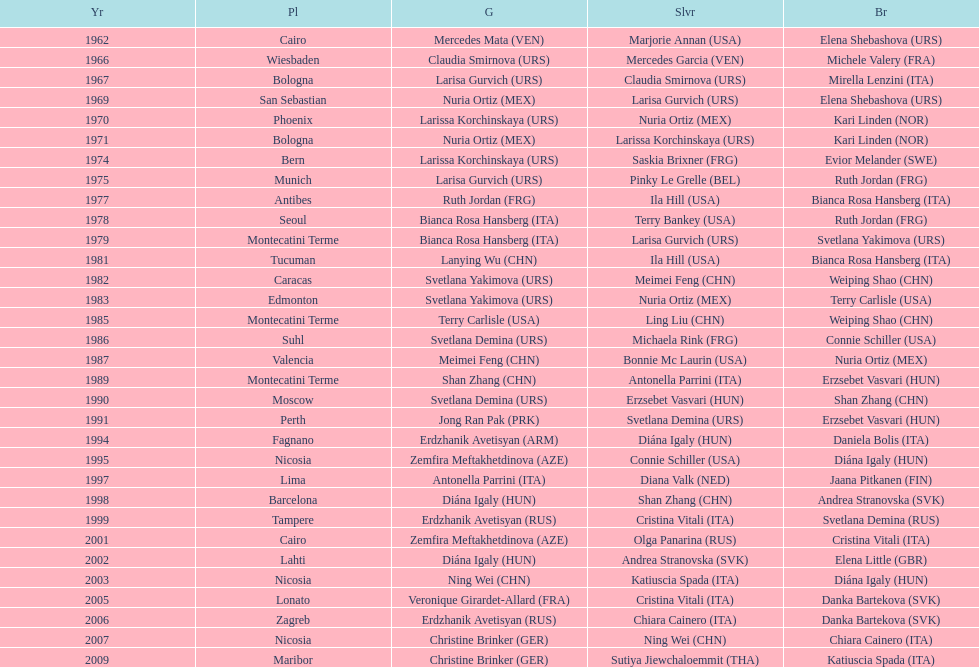Who won the only gold medal in 1962? Mercedes Mata. 